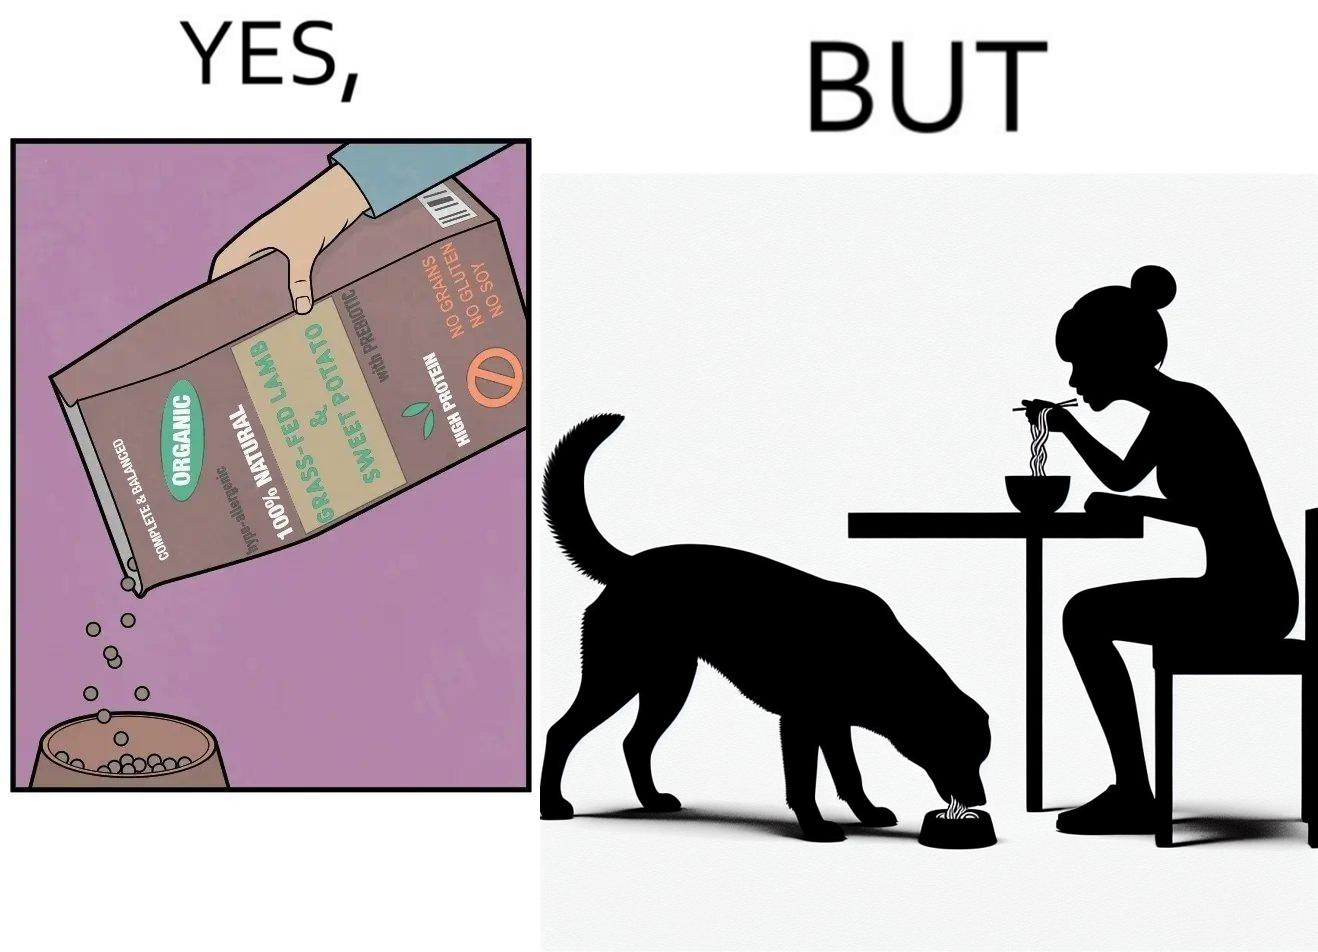Would you classify this image as satirical? Yes, this image is satirical. 